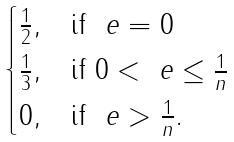Convert formula to latex. <formula><loc_0><loc_0><loc_500><loc_500>\begin{cases} \frac { 1 } { 2 } , & \text {if} \ \ e = 0 \\ \frac { 1 } { 3 } , & \text {if} \ 0 < \ e \leq \frac { 1 } { n } \\ 0 , & \text {if} \ \ e > \frac { 1 } { n } . \end{cases}</formula> 